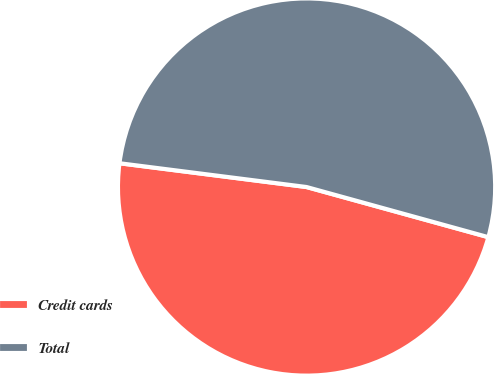<chart> <loc_0><loc_0><loc_500><loc_500><pie_chart><fcel>Credit cards<fcel>Total<nl><fcel>47.73%<fcel>52.27%<nl></chart> 